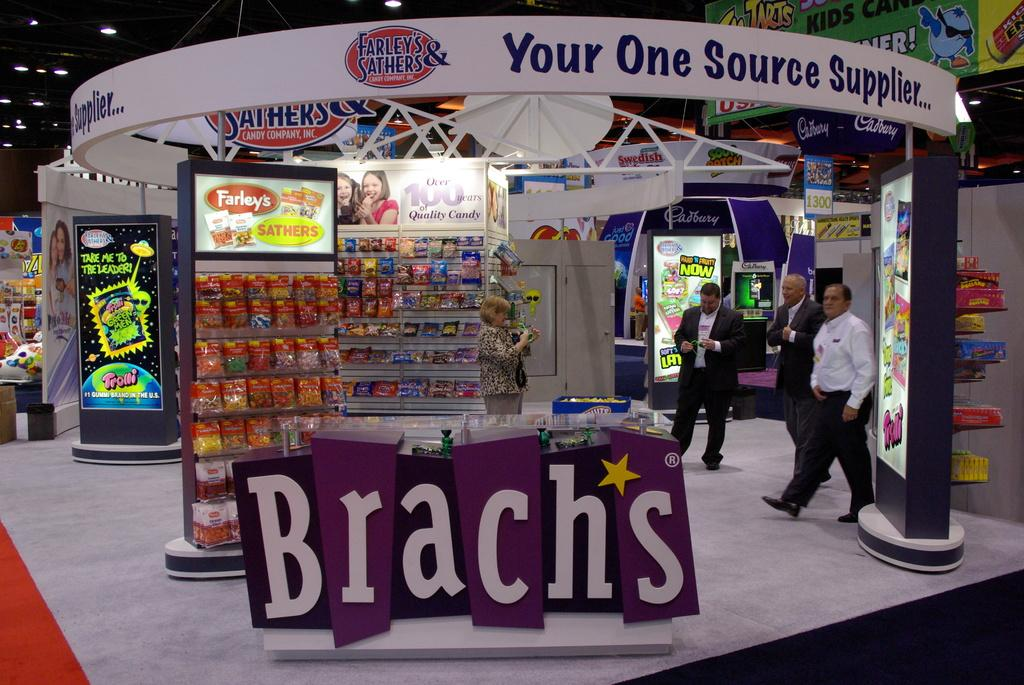<image>
Describe the image concisely. Three men standing in an area that says "Brach's" in purple. 